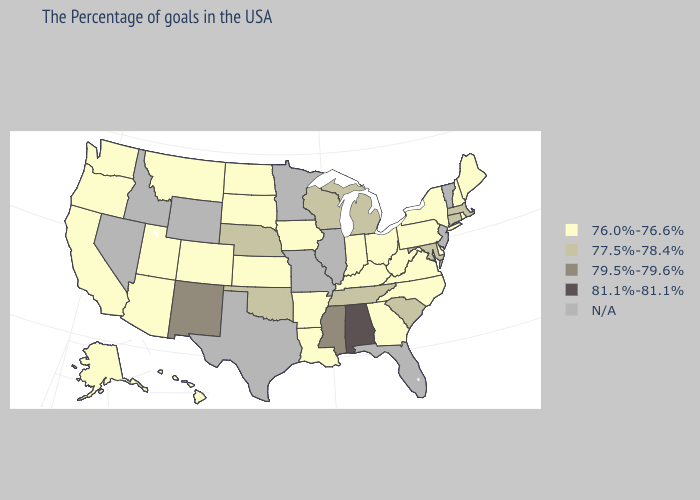Does Oregon have the lowest value in the West?
Keep it brief. Yes. Name the states that have a value in the range 81.1%-81.1%?
Keep it brief. Alabama. How many symbols are there in the legend?
Answer briefly. 5. What is the value of Delaware?
Concise answer only. 76.0%-76.6%. Name the states that have a value in the range 81.1%-81.1%?
Short answer required. Alabama. What is the value of Georgia?
Quick response, please. 76.0%-76.6%. Which states have the lowest value in the MidWest?
Keep it brief. Ohio, Indiana, Iowa, Kansas, South Dakota, North Dakota. Which states hav the highest value in the MidWest?
Write a very short answer. Michigan, Wisconsin, Nebraska. What is the highest value in the South ?
Short answer required. 81.1%-81.1%. What is the lowest value in states that border Montana?
Concise answer only. 76.0%-76.6%. Name the states that have a value in the range 79.5%-79.6%?
Write a very short answer. Mississippi, New Mexico. Does the first symbol in the legend represent the smallest category?
Be succinct. Yes. What is the value of Georgia?
Write a very short answer. 76.0%-76.6%. 